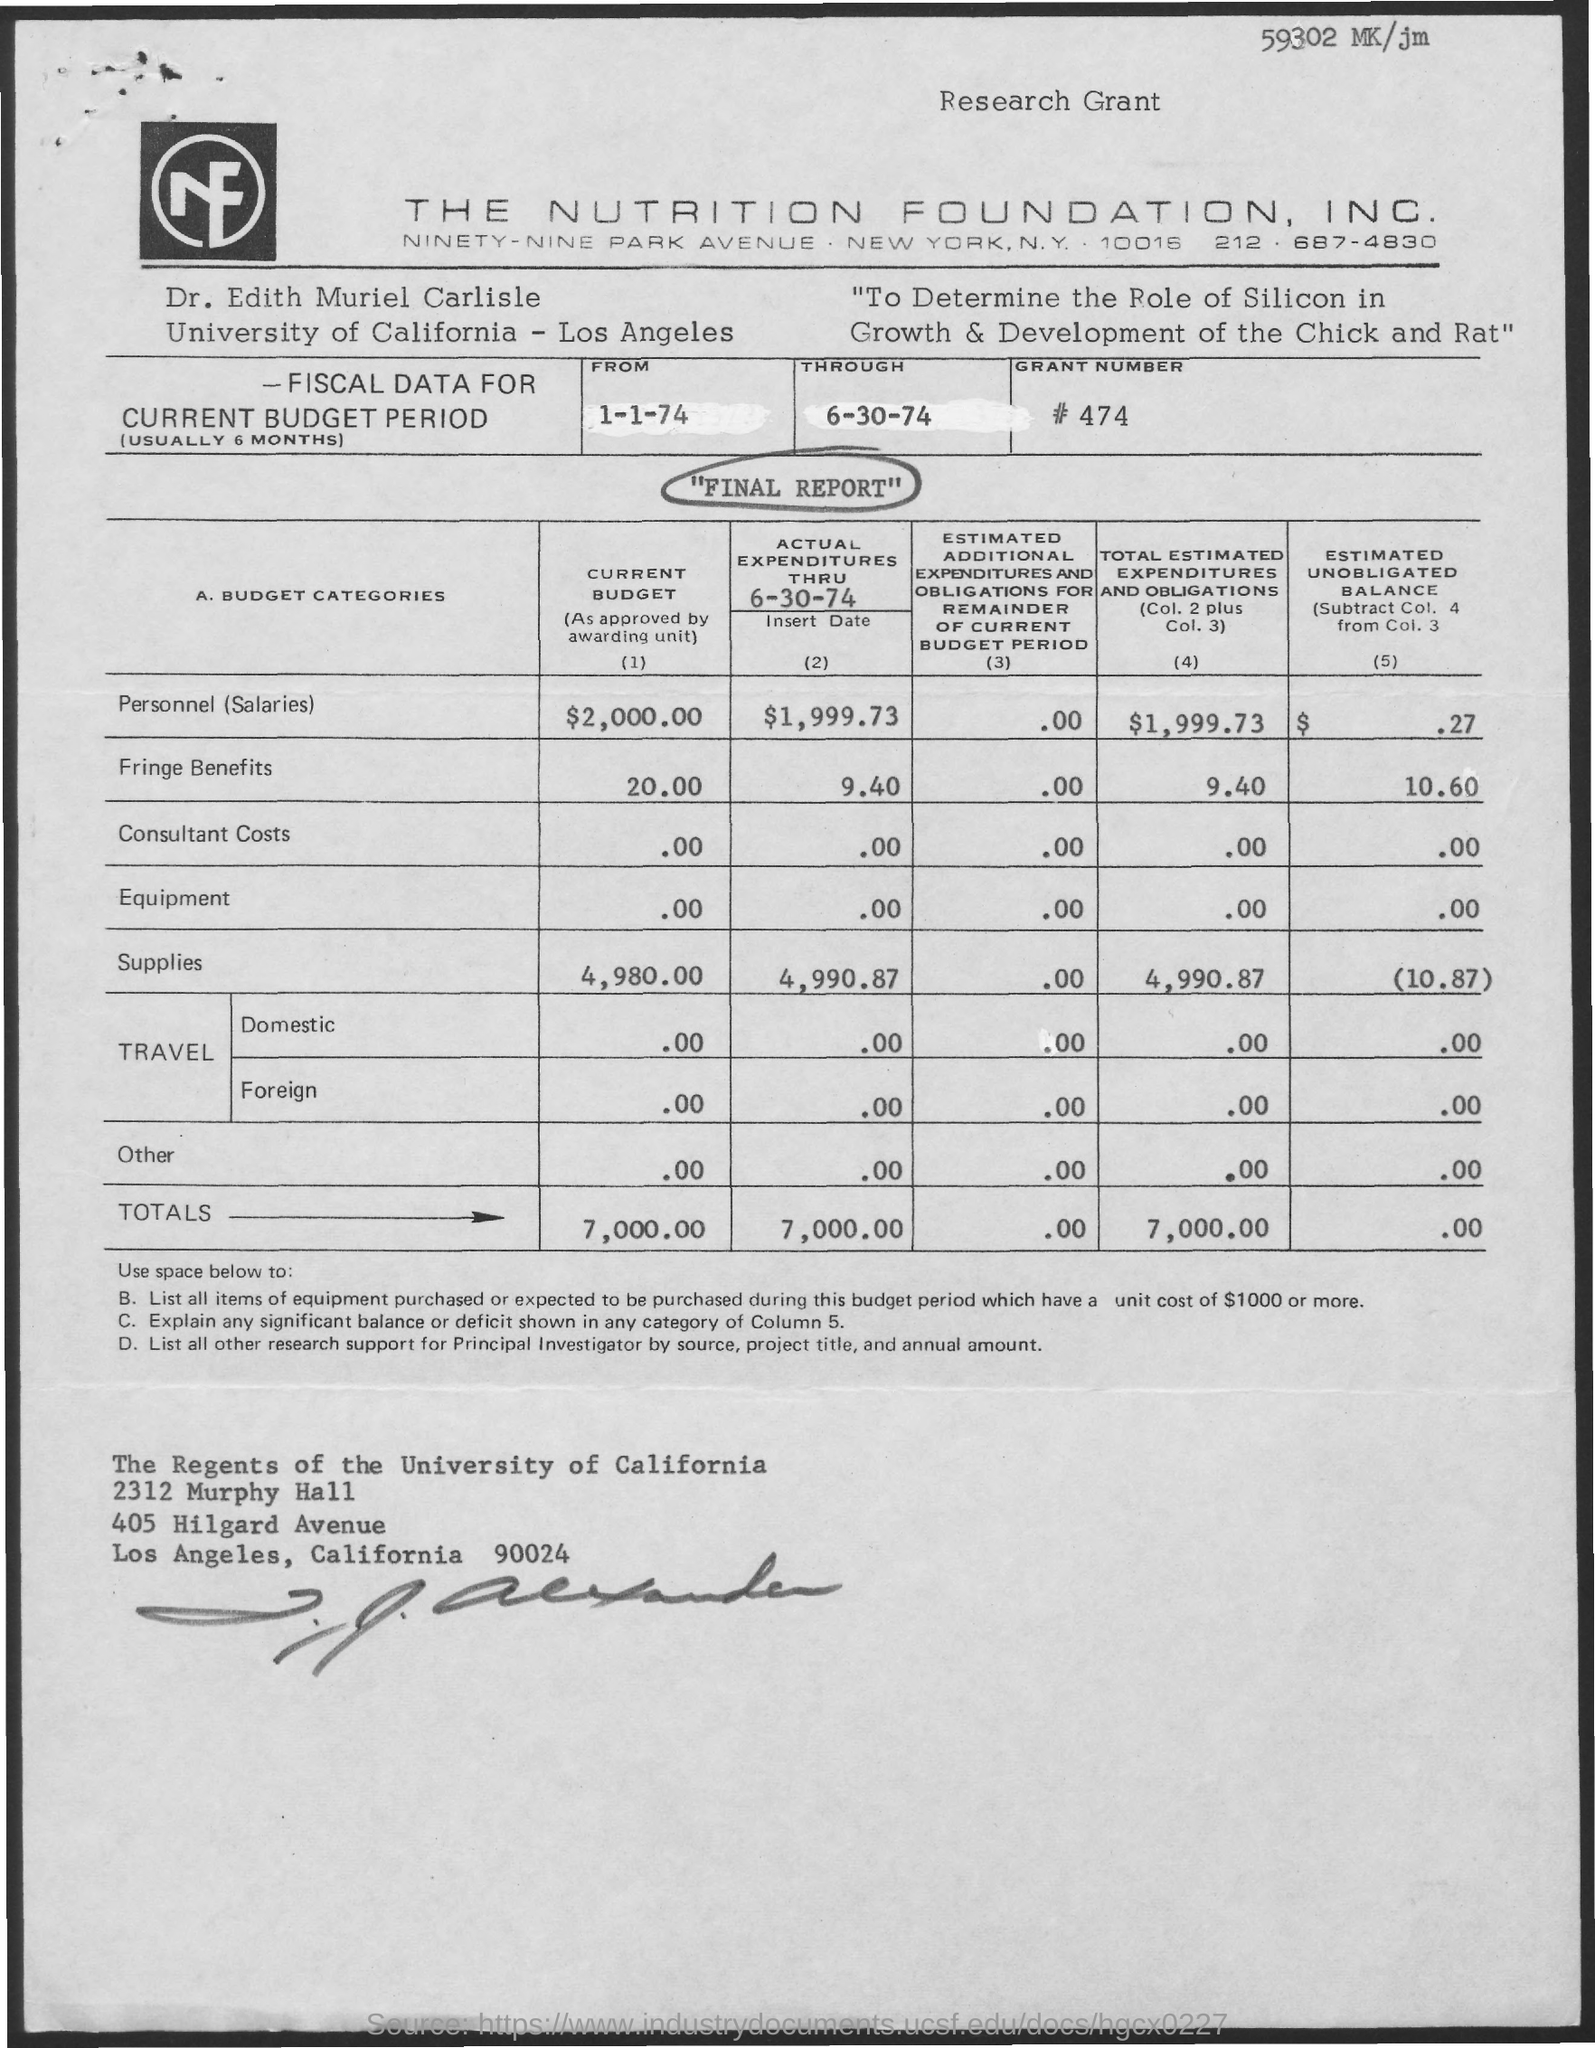What is the total of current budget?
Your answer should be very brief. 7,000.00. 